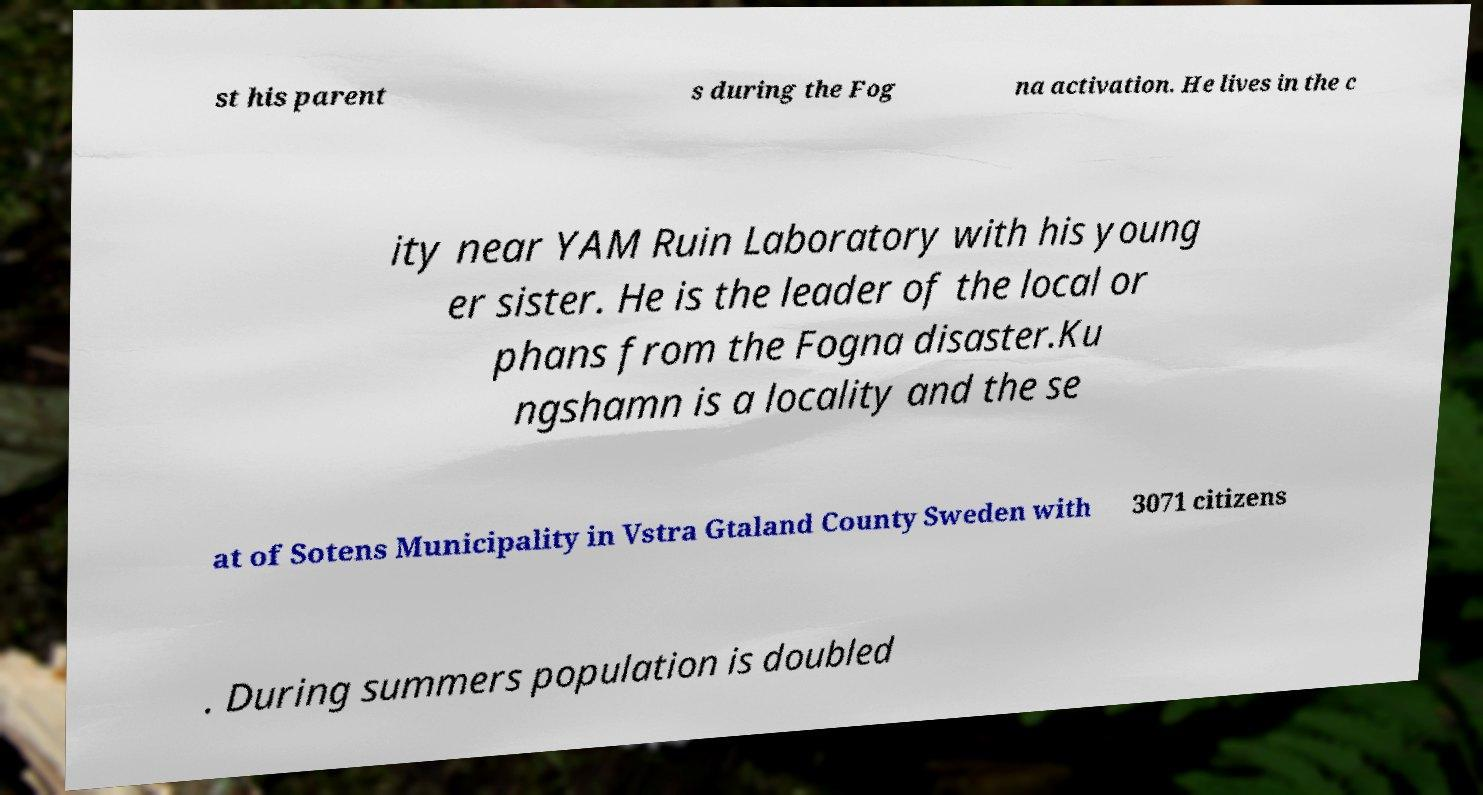I need the written content from this picture converted into text. Can you do that? st his parent s during the Fog na activation. He lives in the c ity near YAM Ruin Laboratory with his young er sister. He is the leader of the local or phans from the Fogna disaster.Ku ngshamn is a locality and the se at of Sotens Municipality in Vstra Gtaland County Sweden with 3071 citizens . During summers population is doubled 